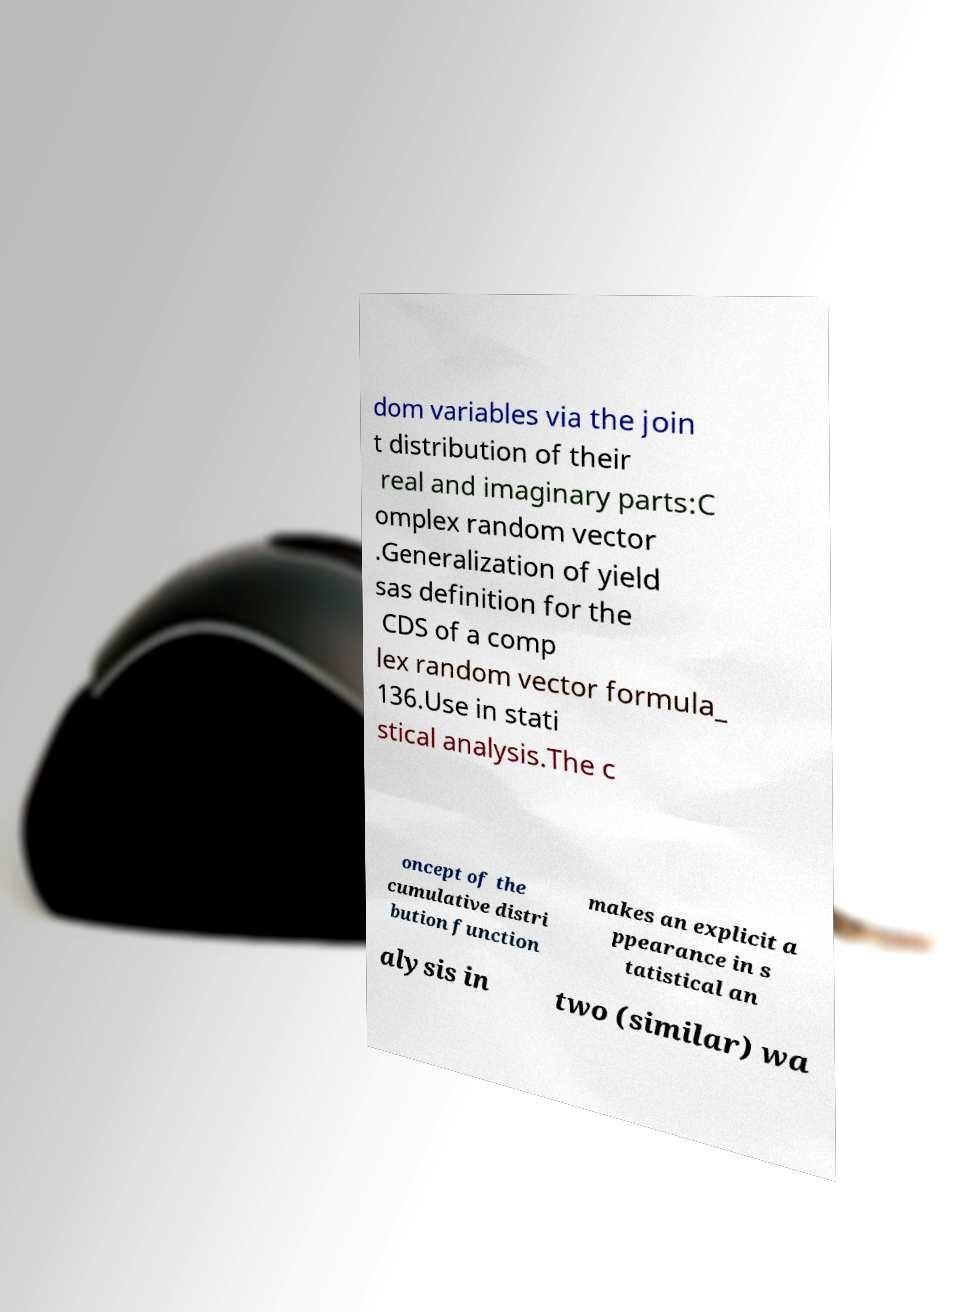Could you assist in decoding the text presented in this image and type it out clearly? dom variables via the join t distribution of their real and imaginary parts:C omplex random vector .Generalization of yield sas definition for the CDS of a comp lex random vector formula_ 136.Use in stati stical analysis.The c oncept of the cumulative distri bution function makes an explicit a ppearance in s tatistical an alysis in two (similar) wa 